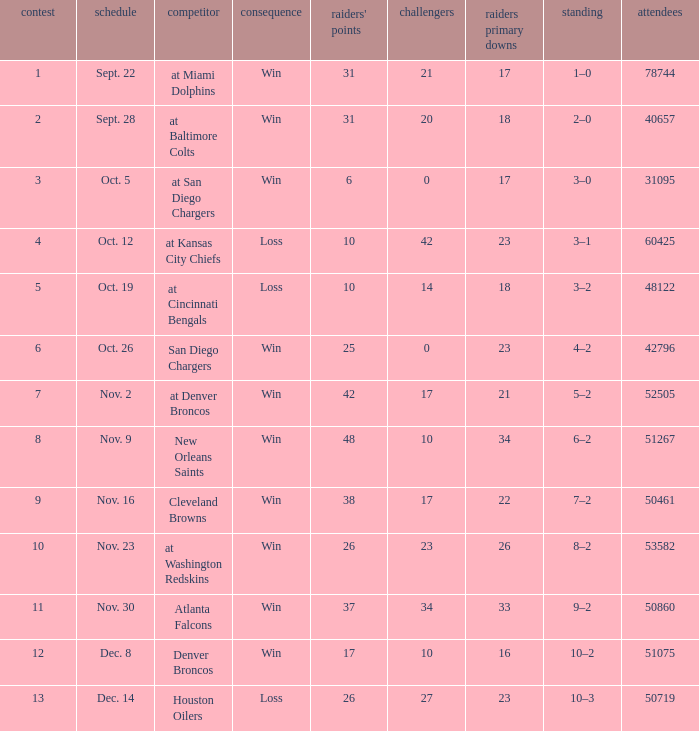What's the record in the game played against 42? 3–1. 